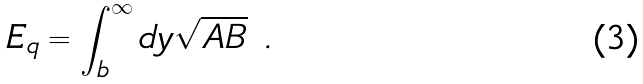<formula> <loc_0><loc_0><loc_500><loc_500>E _ { q } = \int _ { b } ^ { \infty } d y \sqrt { A B } \ .</formula> 